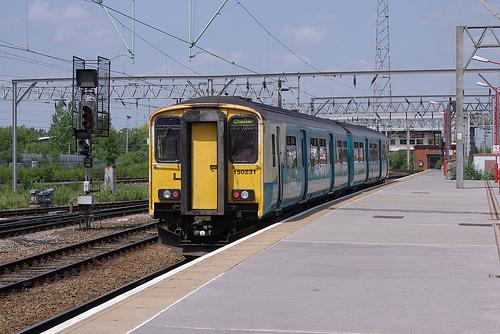Question: what is the color of train back?
Choices:
A. Red.
B. Yellow.
C. Black.
D. White.
Answer with the letter. Answer: B Question: when is the image taken?
Choices:
A. Train is stopped.
B. During the day.
C. During nightime.
D. Afternoon.
Answer with the letter. Answer: A Question: what is the use of train?
Choices:
A. Travel.
B. Hauling items.
C. Viewing scenery.
D. Reliving history.
Answer with the letter. Answer: A Question: how would you describe the weather?
Choices:
A. Cold.
B. Mostly sunny.
C. Hazy.
D. Gloomy.
Answer with the letter. Answer: B Question: what is on the train's right side?
Choices:
A. Passengers.
B. A bridge.
C. The platform.
D. A church.
Answer with the letter. Answer: C Question: what does the train transport?
Choices:
A. Cargo.
B. Cars.
C. Coal.
D. People.
Answer with the letter. Answer: D 